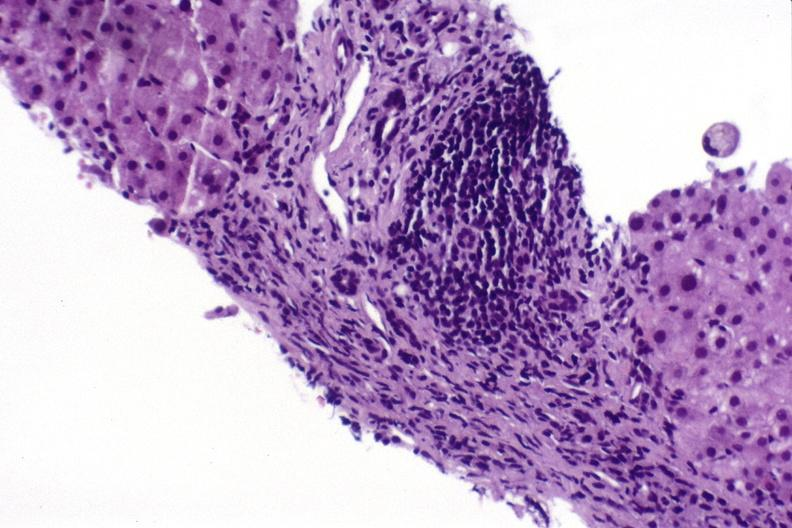s liver present?
Answer the question using a single word or phrase. Yes 